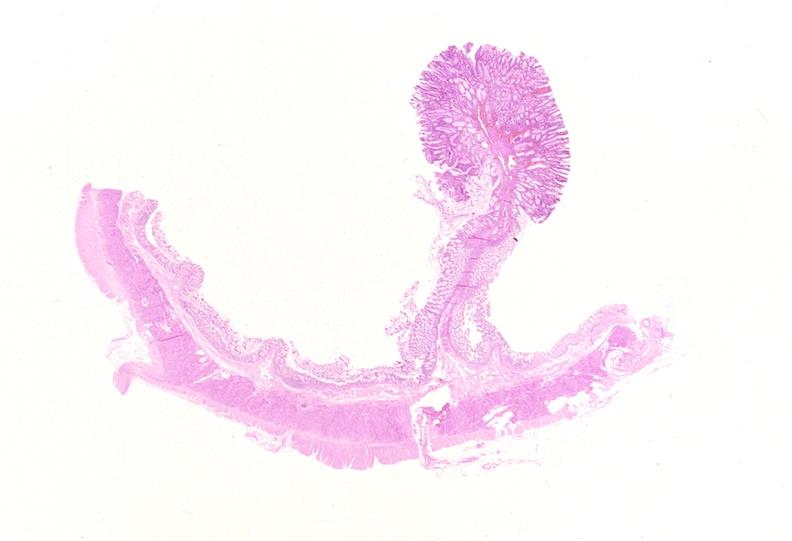does this image show colon, adenomatous polyp?
Answer the question using a single word or phrase. Yes 